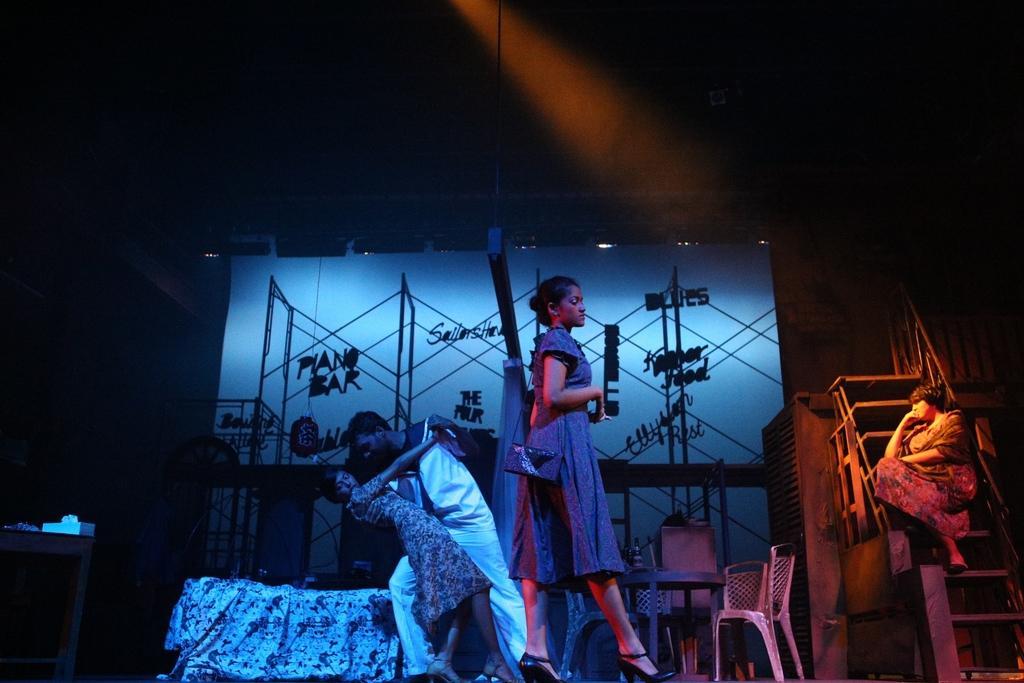Can you describe this image briefly? In the center of the image there are three people. In the background of the image there is a screen with some text. There is a table. There are chairs. To the right side of the image there are staircase. There is a lady sitting on it. To the left side of the image there is a table on which there are objects. 